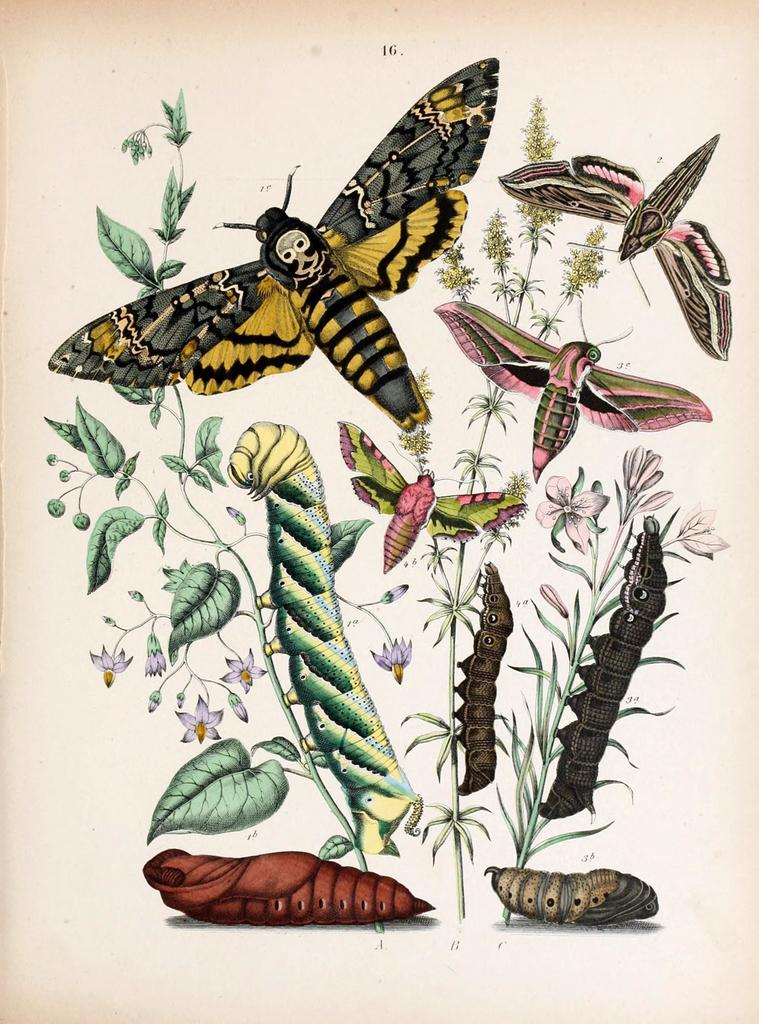What is the main subject of the image? The image is of a paper. What type of living organisms can be seen on the paper? There are plants, flowers, and insects depicted on the paper. What else is featured on the paper besides the images? There is text present on the paper. What type of poison is being used by the insects on the paper? There is no indication in the image that any poison is being used by the insects, as the image is a depiction on a paper and not a real-life scenario. 